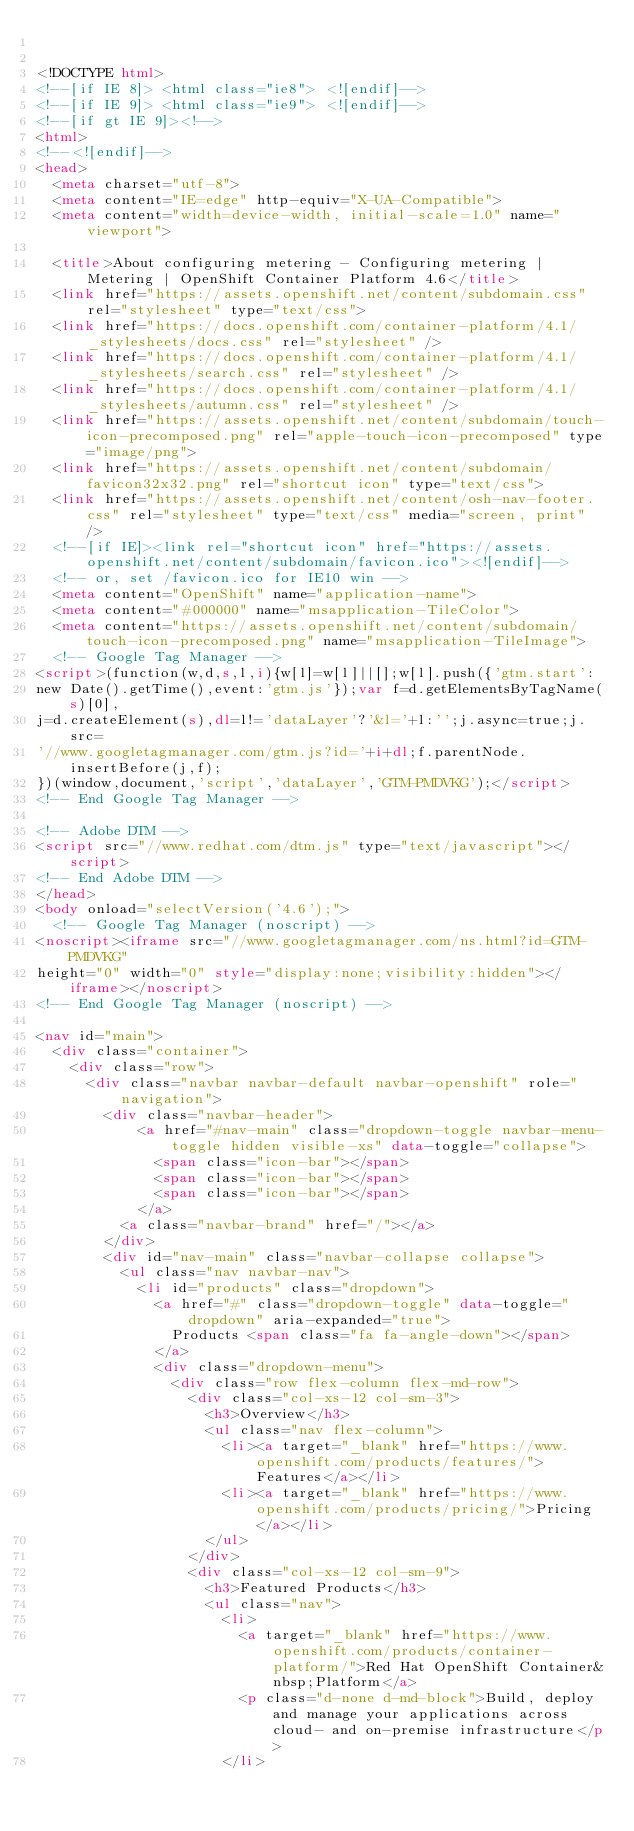Convert code to text. <code><loc_0><loc_0><loc_500><loc_500><_HTML_>

<!DOCTYPE html>
<!--[if IE 8]> <html class="ie8"> <![endif]-->
<!--[if IE 9]> <html class="ie9"> <![endif]-->
<!--[if gt IE 9]><!-->
<html>
<!--<![endif]-->
<head>
  <meta charset="utf-8">
  <meta content="IE=edge" http-equiv="X-UA-Compatible">
  <meta content="width=device-width, initial-scale=1.0" name="viewport">
  
  <title>About configuring metering - Configuring metering | Metering | OpenShift Container Platform 4.6</title>
  <link href="https://assets.openshift.net/content/subdomain.css" rel="stylesheet" type="text/css">
  <link href="https://docs.openshift.com/container-platform/4.1/_stylesheets/docs.css" rel="stylesheet" />
  <link href="https://docs.openshift.com/container-platform/4.1/_stylesheets/search.css" rel="stylesheet" />
  <link href="https://docs.openshift.com/container-platform/4.1/_stylesheets/autumn.css" rel="stylesheet" />
  <link href="https://assets.openshift.net/content/subdomain/touch-icon-precomposed.png" rel="apple-touch-icon-precomposed" type="image/png">
  <link href="https://assets.openshift.net/content/subdomain/favicon32x32.png" rel="shortcut icon" type="text/css">
  <link href="https://assets.openshift.net/content/osh-nav-footer.css" rel="stylesheet" type="text/css" media="screen, print" />
  <!--[if IE]><link rel="shortcut icon" href="https://assets.openshift.net/content/subdomain/favicon.ico"><![endif]-->
  <!-- or, set /favicon.ico for IE10 win -->
  <meta content="OpenShift" name="application-name">
  <meta content="#000000" name="msapplication-TileColor">
  <meta content="https://assets.openshift.net/content/subdomain/touch-icon-precomposed.png" name="msapplication-TileImage">
  <!-- Google Tag Manager -->
<script>(function(w,d,s,l,i){w[l]=w[l]||[];w[l].push({'gtm.start':
new Date().getTime(),event:'gtm.js'});var f=d.getElementsByTagName(s)[0],
j=d.createElement(s),dl=l!='dataLayer'?'&l='+l:'';j.async=true;j.src=
'//www.googletagmanager.com/gtm.js?id='+i+dl;f.parentNode.insertBefore(j,f);
})(window,document,'script','dataLayer','GTM-PMDVKG');</script>
<!-- End Google Tag Manager -->

<!-- Adobe DTM -->
<script src="//www.redhat.com/dtm.js" type="text/javascript"></script>
<!-- End Adobe DTM -->
</head>
<body onload="selectVersion('4.6');">
  <!-- Google Tag Manager (noscript) -->
<noscript><iframe src="//www.googletagmanager.com/ns.html?id=GTM-PMDVKG"
height="0" width="0" style="display:none;visibility:hidden"></iframe></noscript>
<!-- End Google Tag Manager (noscript) -->

<nav id="main">
  <div class="container">
    <div class="row">
      <div class="navbar navbar-default navbar-openshift" role="navigation">
        <div class="navbar-header">
            <a href="#nav-main" class="dropdown-toggle navbar-menu-toggle hidden visible-xs" data-toggle="collapse">
              <span class="icon-bar"></span>
              <span class="icon-bar"></span>
              <span class="icon-bar"></span>
            </a>
          <a class="navbar-brand" href="/"></a>
        </div>
        <div id="nav-main" class="navbar-collapse collapse">
          <ul class="nav navbar-nav">
            <li id="products" class="dropdown">
              <a href="#" class="dropdown-toggle" data-toggle="dropdown" aria-expanded="true">
                Products <span class="fa fa-angle-down"></span>
              </a>
              <div class="dropdown-menu">
                <div class="row flex-column flex-md-row">
                  <div class="col-xs-12 col-sm-3">
                    <h3>Overview</h3>
                    <ul class="nav flex-column">
                      <li><a target="_blank" href="https://www.openshift.com/products/features/">Features</a></li>
                      <li><a target="_blank" href="https://www.openshift.com/products/pricing/">Pricing</a></li>
                    </ul>
                  </div>
                  <div class="col-xs-12 col-sm-9">
                    <h3>Featured Products</h3>
                    <ul class="nav">
                      <li>
                        <a target="_blank" href="https://www.openshift.com/products/container-platform/">Red Hat OpenShift Container&nbsp;Platform</a>
                        <p class="d-none d-md-block">Build, deploy and manage your applications across cloud- and on-premise infrastructure</p>
                      </li></code> 